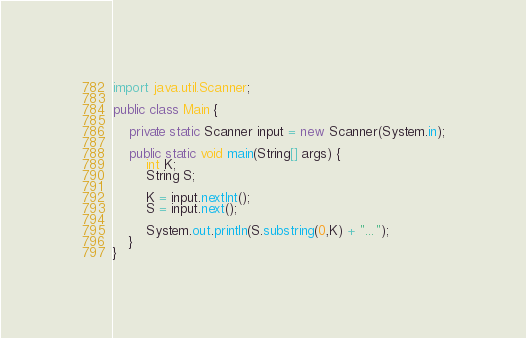Convert code to text. <code><loc_0><loc_0><loc_500><loc_500><_Java_>import java.util.Scanner;

public class Main {

    private static Scanner input = new Scanner(System.in);

    public static void main(String[] args) {
        int K;
        String S;

        K = input.nextInt();
        S = input.next();

        System.out.println(S.substring(0,K) + "...");
    }
}
</code> 